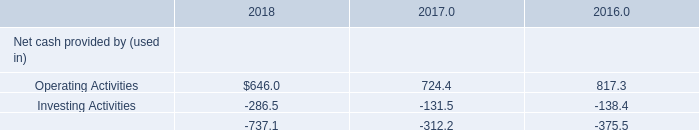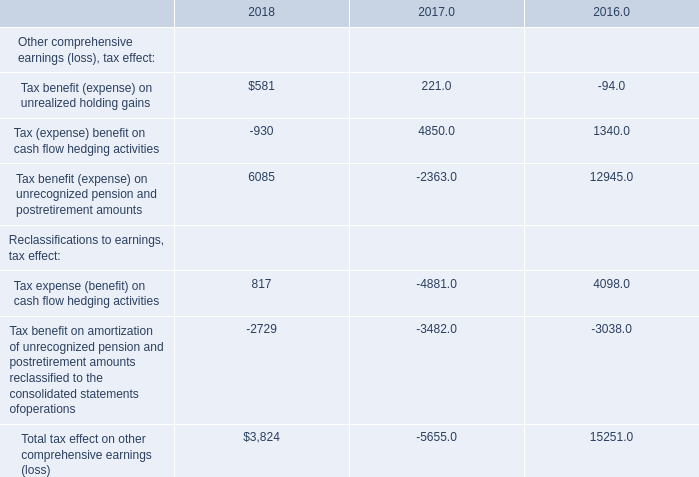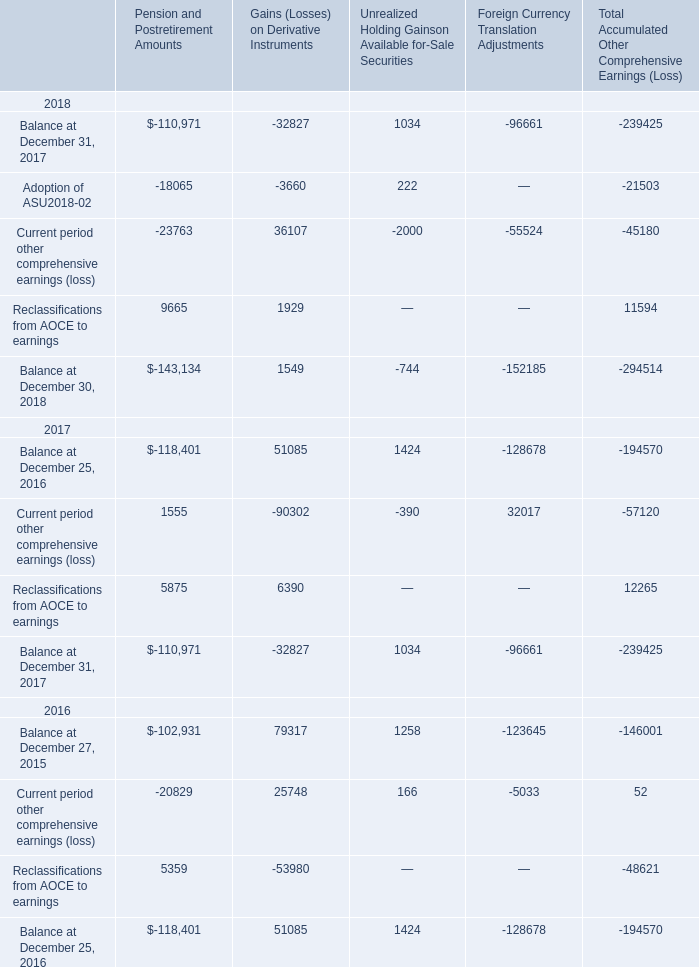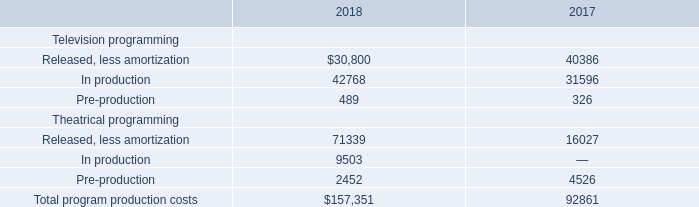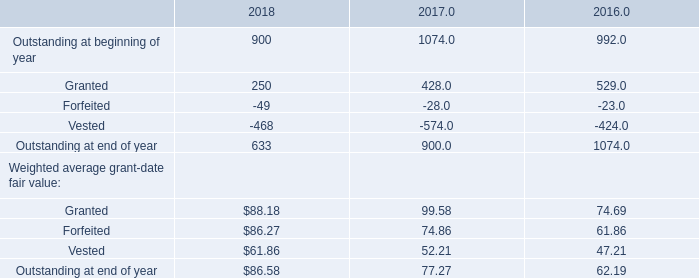What is the proportion of Adoption of ASU2018-02 to the total in 2018? 
Computations: (-18065 / -294514)
Answer: 0.06134. 